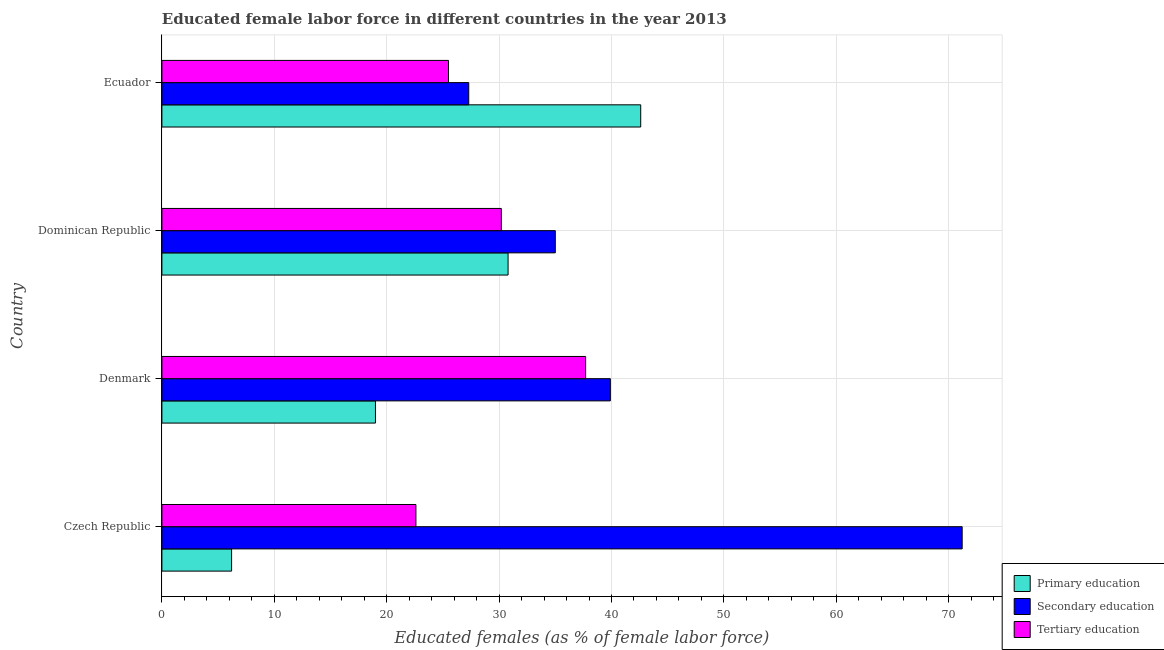How many groups of bars are there?
Offer a very short reply. 4. Are the number of bars per tick equal to the number of legend labels?
Keep it short and to the point. Yes. How many bars are there on the 3rd tick from the bottom?
Your answer should be compact. 3. In how many cases, is the number of bars for a given country not equal to the number of legend labels?
Your response must be concise. 0. What is the percentage of female labor force who received primary education in Ecuador?
Offer a terse response. 42.6. Across all countries, what is the maximum percentage of female labor force who received secondary education?
Provide a short and direct response. 71.2. Across all countries, what is the minimum percentage of female labor force who received primary education?
Your answer should be compact. 6.2. In which country was the percentage of female labor force who received primary education maximum?
Your answer should be compact. Ecuador. In which country was the percentage of female labor force who received primary education minimum?
Offer a terse response. Czech Republic. What is the total percentage of female labor force who received tertiary education in the graph?
Provide a short and direct response. 116. What is the difference between the percentage of female labor force who received tertiary education in Czech Republic and the percentage of female labor force who received secondary education in Dominican Republic?
Your response must be concise. -12.4. In how many countries, is the percentage of female labor force who received primary education greater than 14 %?
Offer a very short reply. 3. What is the ratio of the percentage of female labor force who received secondary education in Czech Republic to that in Ecuador?
Your response must be concise. 2.61. Is the percentage of female labor force who received primary education in Czech Republic less than that in Denmark?
Keep it short and to the point. Yes. What is the difference between the highest and the second highest percentage of female labor force who received tertiary education?
Give a very brief answer. 7.5. What is the difference between the highest and the lowest percentage of female labor force who received primary education?
Make the answer very short. 36.4. What does the 1st bar from the top in Czech Republic represents?
Ensure brevity in your answer.  Tertiary education. What does the 3rd bar from the bottom in Dominican Republic represents?
Give a very brief answer. Tertiary education. Is it the case that in every country, the sum of the percentage of female labor force who received primary education and percentage of female labor force who received secondary education is greater than the percentage of female labor force who received tertiary education?
Provide a short and direct response. Yes. How many countries are there in the graph?
Ensure brevity in your answer.  4. Does the graph contain grids?
Keep it short and to the point. Yes. Where does the legend appear in the graph?
Offer a terse response. Bottom right. What is the title of the graph?
Make the answer very short. Educated female labor force in different countries in the year 2013. Does "Refusal of sex" appear as one of the legend labels in the graph?
Provide a short and direct response. No. What is the label or title of the X-axis?
Make the answer very short. Educated females (as % of female labor force). What is the Educated females (as % of female labor force) of Primary education in Czech Republic?
Keep it short and to the point. 6.2. What is the Educated females (as % of female labor force) in Secondary education in Czech Republic?
Ensure brevity in your answer.  71.2. What is the Educated females (as % of female labor force) of Tertiary education in Czech Republic?
Give a very brief answer. 22.6. What is the Educated females (as % of female labor force) of Primary education in Denmark?
Your response must be concise. 19. What is the Educated females (as % of female labor force) in Secondary education in Denmark?
Your answer should be compact. 39.9. What is the Educated females (as % of female labor force) of Tertiary education in Denmark?
Offer a terse response. 37.7. What is the Educated females (as % of female labor force) in Primary education in Dominican Republic?
Your answer should be compact. 30.8. What is the Educated females (as % of female labor force) of Secondary education in Dominican Republic?
Your response must be concise. 35. What is the Educated females (as % of female labor force) in Tertiary education in Dominican Republic?
Offer a very short reply. 30.2. What is the Educated females (as % of female labor force) of Primary education in Ecuador?
Your answer should be very brief. 42.6. What is the Educated females (as % of female labor force) of Secondary education in Ecuador?
Give a very brief answer. 27.3. What is the Educated females (as % of female labor force) of Tertiary education in Ecuador?
Provide a succinct answer. 25.5. Across all countries, what is the maximum Educated females (as % of female labor force) in Primary education?
Provide a short and direct response. 42.6. Across all countries, what is the maximum Educated females (as % of female labor force) in Secondary education?
Give a very brief answer. 71.2. Across all countries, what is the maximum Educated females (as % of female labor force) in Tertiary education?
Provide a short and direct response. 37.7. Across all countries, what is the minimum Educated females (as % of female labor force) of Primary education?
Keep it short and to the point. 6.2. Across all countries, what is the minimum Educated females (as % of female labor force) in Secondary education?
Offer a terse response. 27.3. Across all countries, what is the minimum Educated females (as % of female labor force) of Tertiary education?
Offer a terse response. 22.6. What is the total Educated females (as % of female labor force) in Primary education in the graph?
Your answer should be very brief. 98.6. What is the total Educated females (as % of female labor force) of Secondary education in the graph?
Offer a terse response. 173.4. What is the total Educated females (as % of female labor force) of Tertiary education in the graph?
Provide a short and direct response. 116. What is the difference between the Educated females (as % of female labor force) in Secondary education in Czech Republic and that in Denmark?
Ensure brevity in your answer.  31.3. What is the difference between the Educated females (as % of female labor force) of Tertiary education in Czech Republic and that in Denmark?
Keep it short and to the point. -15.1. What is the difference between the Educated females (as % of female labor force) in Primary education in Czech Republic and that in Dominican Republic?
Give a very brief answer. -24.6. What is the difference between the Educated females (as % of female labor force) of Secondary education in Czech Republic and that in Dominican Republic?
Your response must be concise. 36.2. What is the difference between the Educated females (as % of female labor force) of Tertiary education in Czech Republic and that in Dominican Republic?
Give a very brief answer. -7.6. What is the difference between the Educated females (as % of female labor force) of Primary education in Czech Republic and that in Ecuador?
Provide a succinct answer. -36.4. What is the difference between the Educated females (as % of female labor force) in Secondary education in Czech Republic and that in Ecuador?
Your response must be concise. 43.9. What is the difference between the Educated females (as % of female labor force) in Secondary education in Denmark and that in Dominican Republic?
Give a very brief answer. 4.9. What is the difference between the Educated females (as % of female labor force) of Tertiary education in Denmark and that in Dominican Republic?
Your response must be concise. 7.5. What is the difference between the Educated females (as % of female labor force) in Primary education in Denmark and that in Ecuador?
Make the answer very short. -23.6. What is the difference between the Educated females (as % of female labor force) of Secondary education in Denmark and that in Ecuador?
Provide a short and direct response. 12.6. What is the difference between the Educated females (as % of female labor force) in Primary education in Dominican Republic and that in Ecuador?
Offer a terse response. -11.8. What is the difference between the Educated females (as % of female labor force) in Secondary education in Dominican Republic and that in Ecuador?
Provide a short and direct response. 7.7. What is the difference between the Educated females (as % of female labor force) of Tertiary education in Dominican Republic and that in Ecuador?
Your response must be concise. 4.7. What is the difference between the Educated females (as % of female labor force) of Primary education in Czech Republic and the Educated females (as % of female labor force) of Secondary education in Denmark?
Your answer should be very brief. -33.7. What is the difference between the Educated females (as % of female labor force) in Primary education in Czech Republic and the Educated females (as % of female labor force) in Tertiary education in Denmark?
Give a very brief answer. -31.5. What is the difference between the Educated females (as % of female labor force) of Secondary education in Czech Republic and the Educated females (as % of female labor force) of Tertiary education in Denmark?
Provide a succinct answer. 33.5. What is the difference between the Educated females (as % of female labor force) in Primary education in Czech Republic and the Educated females (as % of female labor force) in Secondary education in Dominican Republic?
Give a very brief answer. -28.8. What is the difference between the Educated females (as % of female labor force) of Primary education in Czech Republic and the Educated females (as % of female labor force) of Secondary education in Ecuador?
Make the answer very short. -21.1. What is the difference between the Educated females (as % of female labor force) of Primary education in Czech Republic and the Educated females (as % of female labor force) of Tertiary education in Ecuador?
Offer a very short reply. -19.3. What is the difference between the Educated females (as % of female labor force) in Secondary education in Czech Republic and the Educated females (as % of female labor force) in Tertiary education in Ecuador?
Your answer should be very brief. 45.7. What is the difference between the Educated females (as % of female labor force) in Primary education in Denmark and the Educated females (as % of female labor force) in Secondary education in Dominican Republic?
Your answer should be very brief. -16. What is the difference between the Educated females (as % of female labor force) in Primary education in Denmark and the Educated females (as % of female labor force) in Tertiary education in Ecuador?
Your answer should be compact. -6.5. What is the difference between the Educated females (as % of female labor force) of Primary education in Dominican Republic and the Educated females (as % of female labor force) of Tertiary education in Ecuador?
Your answer should be compact. 5.3. What is the average Educated females (as % of female labor force) in Primary education per country?
Offer a terse response. 24.65. What is the average Educated females (as % of female labor force) of Secondary education per country?
Provide a short and direct response. 43.35. What is the average Educated females (as % of female labor force) of Tertiary education per country?
Give a very brief answer. 29. What is the difference between the Educated females (as % of female labor force) of Primary education and Educated females (as % of female labor force) of Secondary education in Czech Republic?
Provide a succinct answer. -65. What is the difference between the Educated females (as % of female labor force) in Primary education and Educated females (as % of female labor force) in Tertiary education in Czech Republic?
Give a very brief answer. -16.4. What is the difference between the Educated females (as % of female labor force) of Secondary education and Educated females (as % of female labor force) of Tertiary education in Czech Republic?
Keep it short and to the point. 48.6. What is the difference between the Educated females (as % of female labor force) of Primary education and Educated females (as % of female labor force) of Secondary education in Denmark?
Your response must be concise. -20.9. What is the difference between the Educated females (as % of female labor force) of Primary education and Educated females (as % of female labor force) of Tertiary education in Denmark?
Make the answer very short. -18.7. What is the difference between the Educated females (as % of female labor force) of Secondary education and Educated females (as % of female labor force) of Tertiary education in Denmark?
Your answer should be very brief. 2.2. What is the difference between the Educated females (as % of female labor force) of Primary education and Educated females (as % of female labor force) of Secondary education in Dominican Republic?
Offer a terse response. -4.2. What is the difference between the Educated females (as % of female labor force) in Primary education and Educated females (as % of female labor force) in Tertiary education in Dominican Republic?
Provide a succinct answer. 0.6. What is the difference between the Educated females (as % of female labor force) of Primary education and Educated females (as % of female labor force) of Tertiary education in Ecuador?
Provide a succinct answer. 17.1. What is the difference between the Educated females (as % of female labor force) in Secondary education and Educated females (as % of female labor force) in Tertiary education in Ecuador?
Make the answer very short. 1.8. What is the ratio of the Educated females (as % of female labor force) of Primary education in Czech Republic to that in Denmark?
Your response must be concise. 0.33. What is the ratio of the Educated females (as % of female labor force) in Secondary education in Czech Republic to that in Denmark?
Your answer should be very brief. 1.78. What is the ratio of the Educated females (as % of female labor force) of Tertiary education in Czech Republic to that in Denmark?
Your response must be concise. 0.6. What is the ratio of the Educated females (as % of female labor force) of Primary education in Czech Republic to that in Dominican Republic?
Keep it short and to the point. 0.2. What is the ratio of the Educated females (as % of female labor force) of Secondary education in Czech Republic to that in Dominican Republic?
Your answer should be very brief. 2.03. What is the ratio of the Educated females (as % of female labor force) in Tertiary education in Czech Republic to that in Dominican Republic?
Keep it short and to the point. 0.75. What is the ratio of the Educated females (as % of female labor force) of Primary education in Czech Republic to that in Ecuador?
Your answer should be compact. 0.15. What is the ratio of the Educated females (as % of female labor force) in Secondary education in Czech Republic to that in Ecuador?
Offer a terse response. 2.61. What is the ratio of the Educated females (as % of female labor force) of Tertiary education in Czech Republic to that in Ecuador?
Ensure brevity in your answer.  0.89. What is the ratio of the Educated females (as % of female labor force) in Primary education in Denmark to that in Dominican Republic?
Keep it short and to the point. 0.62. What is the ratio of the Educated females (as % of female labor force) of Secondary education in Denmark to that in Dominican Republic?
Give a very brief answer. 1.14. What is the ratio of the Educated females (as % of female labor force) of Tertiary education in Denmark to that in Dominican Republic?
Your answer should be very brief. 1.25. What is the ratio of the Educated females (as % of female labor force) in Primary education in Denmark to that in Ecuador?
Offer a very short reply. 0.45. What is the ratio of the Educated females (as % of female labor force) of Secondary education in Denmark to that in Ecuador?
Your answer should be compact. 1.46. What is the ratio of the Educated females (as % of female labor force) of Tertiary education in Denmark to that in Ecuador?
Give a very brief answer. 1.48. What is the ratio of the Educated females (as % of female labor force) of Primary education in Dominican Republic to that in Ecuador?
Your answer should be compact. 0.72. What is the ratio of the Educated females (as % of female labor force) of Secondary education in Dominican Republic to that in Ecuador?
Give a very brief answer. 1.28. What is the ratio of the Educated females (as % of female labor force) of Tertiary education in Dominican Republic to that in Ecuador?
Offer a terse response. 1.18. What is the difference between the highest and the second highest Educated females (as % of female labor force) of Primary education?
Provide a succinct answer. 11.8. What is the difference between the highest and the second highest Educated females (as % of female labor force) of Secondary education?
Ensure brevity in your answer.  31.3. What is the difference between the highest and the second highest Educated females (as % of female labor force) of Tertiary education?
Give a very brief answer. 7.5. What is the difference between the highest and the lowest Educated females (as % of female labor force) of Primary education?
Ensure brevity in your answer.  36.4. What is the difference between the highest and the lowest Educated females (as % of female labor force) of Secondary education?
Your answer should be very brief. 43.9. What is the difference between the highest and the lowest Educated females (as % of female labor force) of Tertiary education?
Offer a very short reply. 15.1. 